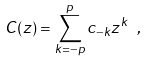<formula> <loc_0><loc_0><loc_500><loc_500>C ( z ) = \sum _ { k = - p } ^ { p } c _ { - k } z ^ { k } \ ,</formula> 